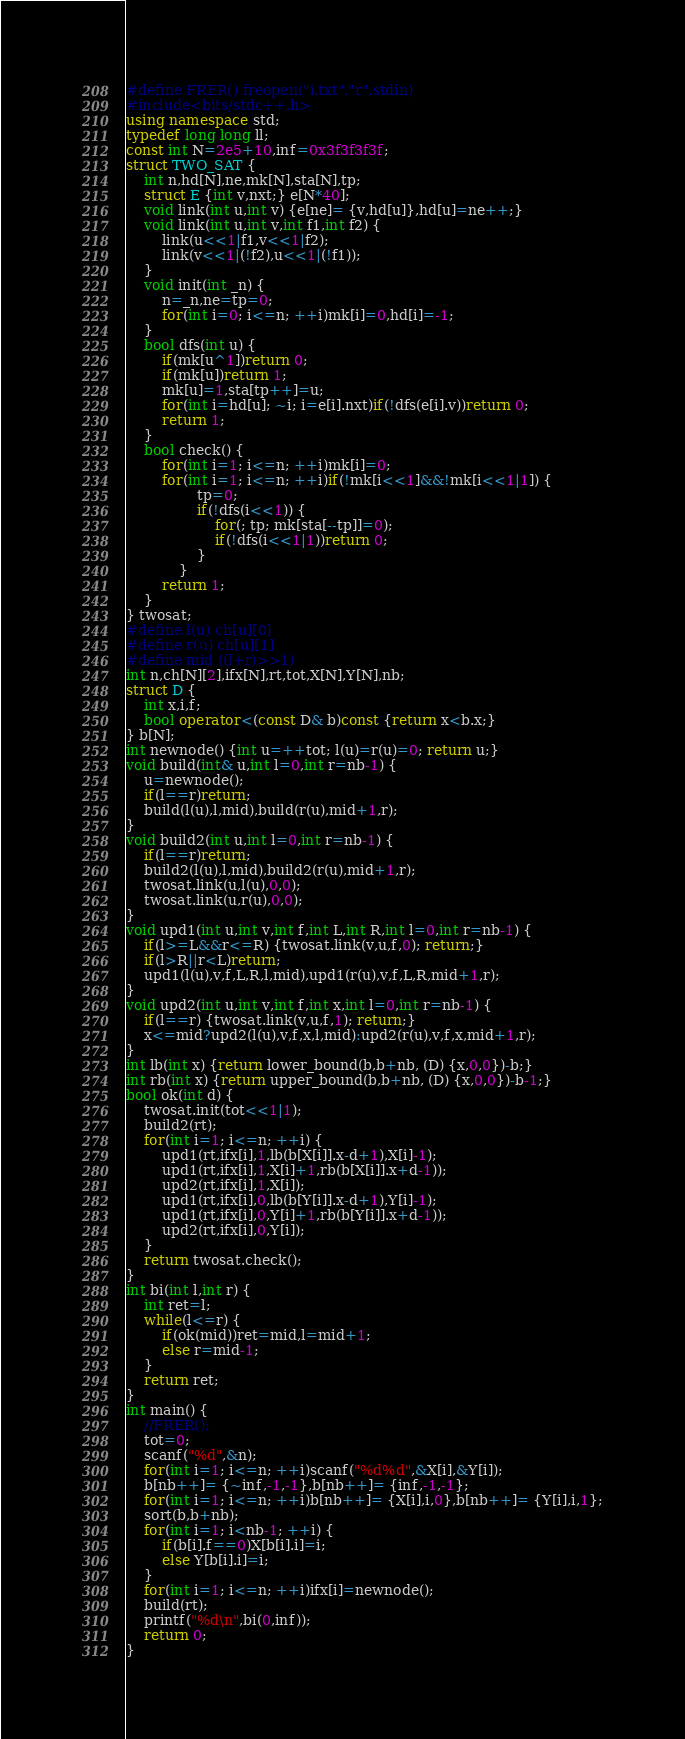Convert code to text. <code><loc_0><loc_0><loc_500><loc_500><_C++_>#define FRER() freopen("i.txt","r",stdin)
#include<bits/stdc++.h>
using namespace std;
typedef long long ll;
const int N=2e5+10,inf=0x3f3f3f3f;
struct TWO_SAT {
    int n,hd[N],ne,mk[N],sta[N],tp;
    struct E {int v,nxt;} e[N*40];
    void link(int u,int v) {e[ne]= {v,hd[u]},hd[u]=ne++;}
    void link(int u,int v,int f1,int f2) {
        link(u<<1|f1,v<<1|f2);
        link(v<<1|(!f2),u<<1|(!f1));
    }
    void init(int _n) {
        n=_n,ne=tp=0;
        for(int i=0; i<=n; ++i)mk[i]=0,hd[i]=-1;
    }
    bool dfs(int u) {
        if(mk[u^1])return 0;
        if(mk[u])return 1;
        mk[u]=1,sta[tp++]=u;
        for(int i=hd[u]; ~i; i=e[i].nxt)if(!dfs(e[i].v))return 0;
        return 1;
    }
    bool check() {
        for(int i=1; i<=n; ++i)mk[i]=0;
        for(int i=1; i<=n; ++i)if(!mk[i<<1]&&!mk[i<<1|1]) {
                tp=0;
                if(!dfs(i<<1)) {
                    for(; tp; mk[sta[--tp]]=0);
                    if(!dfs(i<<1|1))return 0;
                }
            }
        return 1;
    }
} twosat;
#define l(u) ch[u][0]
#define r(u) ch[u][1]
#define mid ((l+r)>>1)
int n,ch[N][2],ifx[N],rt,tot,X[N],Y[N],nb;
struct D {
    int x,i,f;
    bool operator<(const D& b)const {return x<b.x;}
} b[N];
int newnode() {int u=++tot; l(u)=r(u)=0; return u;}
void build(int& u,int l=0,int r=nb-1) {
    u=newnode();
    if(l==r)return;
    build(l(u),l,mid),build(r(u),mid+1,r);
}
void build2(int u,int l=0,int r=nb-1) {
    if(l==r)return;
    build2(l(u),l,mid),build2(r(u),mid+1,r);
    twosat.link(u,l(u),0,0);
    twosat.link(u,r(u),0,0);
}
void upd1(int u,int v,int f,int L,int R,int l=0,int r=nb-1) {
    if(l>=L&&r<=R) {twosat.link(v,u,f,0); return;}
    if(l>R||r<L)return;
    upd1(l(u),v,f,L,R,l,mid),upd1(r(u),v,f,L,R,mid+1,r);
}
void upd2(int u,int v,int f,int x,int l=0,int r=nb-1) {
    if(l==r) {twosat.link(v,u,f,1); return;}
    x<=mid?upd2(l(u),v,f,x,l,mid):upd2(r(u),v,f,x,mid+1,r);
}
int lb(int x) {return lower_bound(b,b+nb, (D) {x,0,0})-b;}
int rb(int x) {return upper_bound(b,b+nb, (D) {x,0,0})-b-1;}
bool ok(int d) {
    twosat.init(tot<<1|1);
    build2(rt);
    for(int i=1; i<=n; ++i) {
        upd1(rt,ifx[i],1,lb(b[X[i]].x-d+1),X[i]-1);
        upd1(rt,ifx[i],1,X[i]+1,rb(b[X[i]].x+d-1));
        upd2(rt,ifx[i],1,X[i]);
        upd1(rt,ifx[i],0,lb(b[Y[i]].x-d+1),Y[i]-1);
        upd1(rt,ifx[i],0,Y[i]+1,rb(b[Y[i]].x+d-1));
        upd2(rt,ifx[i],0,Y[i]);
    }
    return twosat.check();
}
int bi(int l,int r) {
    int ret=l;
    while(l<=r) {
        if(ok(mid))ret=mid,l=mid+1;
        else r=mid-1;
    }
    return ret;
}
int main() {
    //FRER();
    tot=0;
    scanf("%d",&n);
    for(int i=1; i<=n; ++i)scanf("%d%d",&X[i],&Y[i]);
    b[nb++]= {~inf,-1,-1},b[nb++]= {inf,-1,-1};
    for(int i=1; i<=n; ++i)b[nb++]= {X[i],i,0},b[nb++]= {Y[i],i,1};
    sort(b,b+nb);
    for(int i=1; i<nb-1; ++i) {
        if(b[i].f==0)X[b[i].i]=i;
        else Y[b[i].i]=i;
    }
    for(int i=1; i<=n; ++i)ifx[i]=newnode();
    build(rt);
    printf("%d\n",bi(0,inf));
    return 0;
}
</code> 